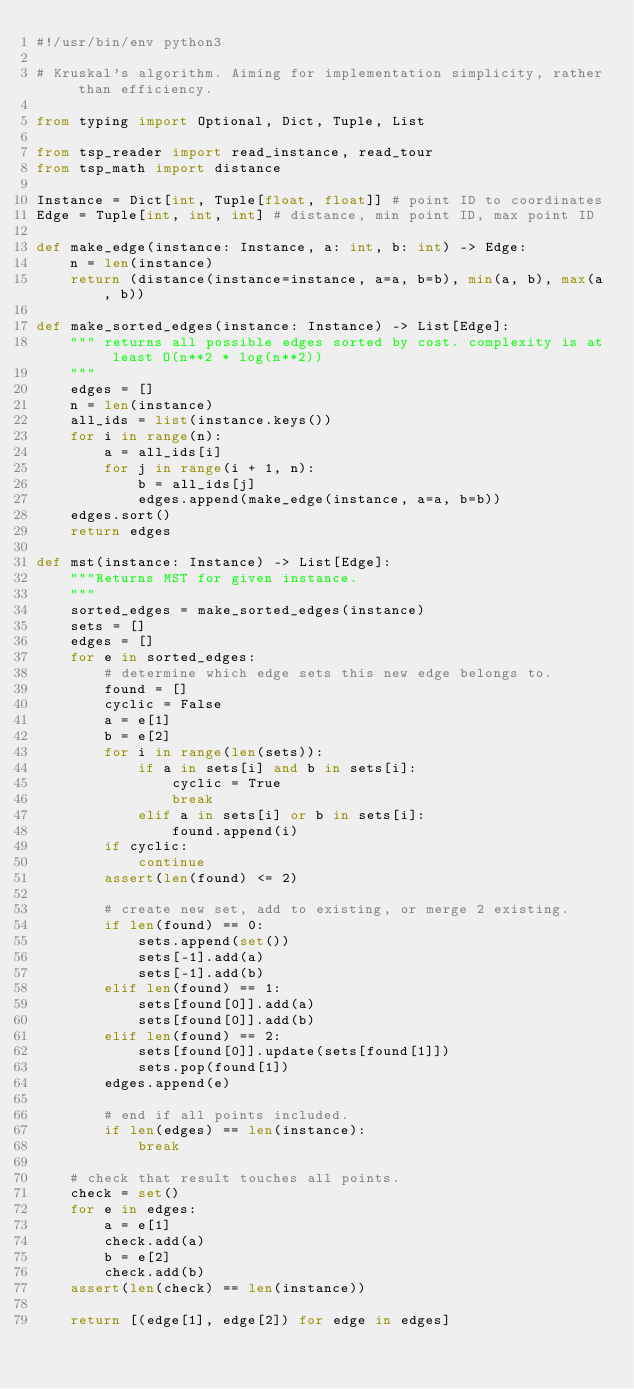<code> <loc_0><loc_0><loc_500><loc_500><_Python_>#!/usr/bin/env python3

# Kruskal's algorithm. Aiming for implementation simplicity, rather than efficiency.

from typing import Optional, Dict, Tuple, List

from tsp_reader import read_instance, read_tour
from tsp_math import distance

Instance = Dict[int, Tuple[float, float]] # point ID to coordinates
Edge = Tuple[int, int, int] # distance, min point ID, max point ID

def make_edge(instance: Instance, a: int, b: int) -> Edge:
    n = len(instance)
    return (distance(instance=instance, a=a, b=b), min(a, b), max(a, b))

def make_sorted_edges(instance: Instance) -> List[Edge]:
    """ returns all possible edges sorted by cost. complexity is at least O(n**2 * log(n**2))
    """
    edges = []
    n = len(instance)
    all_ids = list(instance.keys())
    for i in range(n):
        a = all_ids[i]
        for j in range(i + 1, n):
            b = all_ids[j]
            edges.append(make_edge(instance, a=a, b=b))
    edges.sort()
    return edges

def mst(instance: Instance) -> List[Edge]:
    """Returns MST for given instance.
    """
    sorted_edges = make_sorted_edges(instance)
    sets = []
    edges = []
    for e in sorted_edges:
        # determine which edge sets this new edge belongs to.
        found = []
        cyclic = False
        a = e[1]
        b = e[2]
        for i in range(len(sets)):
            if a in sets[i] and b in sets[i]:
                cyclic = True
                break
            elif a in sets[i] or b in sets[i]:
                found.append(i)
        if cyclic:
            continue
        assert(len(found) <= 2)

        # create new set, add to existing, or merge 2 existing.
        if len(found) == 0:
            sets.append(set())
            sets[-1].add(a)
            sets[-1].add(b)
        elif len(found) == 1:
            sets[found[0]].add(a)
            sets[found[0]].add(b)
        elif len(found) == 2:
            sets[found[0]].update(sets[found[1]])
            sets.pop(found[1])
        edges.append(e)

        # end if all points included.
        if len(edges) == len(instance):
            break

    # check that result touches all points.
    check = set()
    for e in edges:
        a = e[1]
        check.add(a)
        b = e[2]
        check.add(b)
    assert(len(check) == len(instance))

    return [(edge[1], edge[2]) for edge in edges]
</code> 